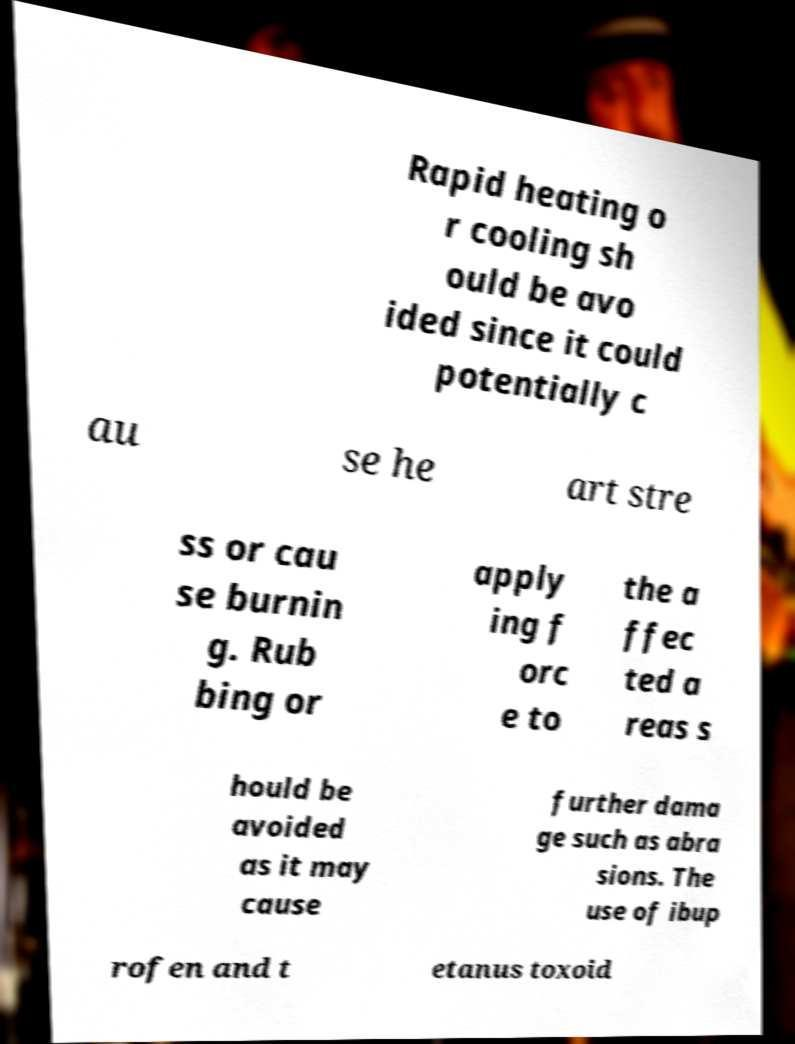Please read and relay the text visible in this image. What does it say? Rapid heating o r cooling sh ould be avo ided since it could potentially c au se he art stre ss or cau se burnin g. Rub bing or apply ing f orc e to the a ffec ted a reas s hould be avoided as it may cause further dama ge such as abra sions. The use of ibup rofen and t etanus toxoid 